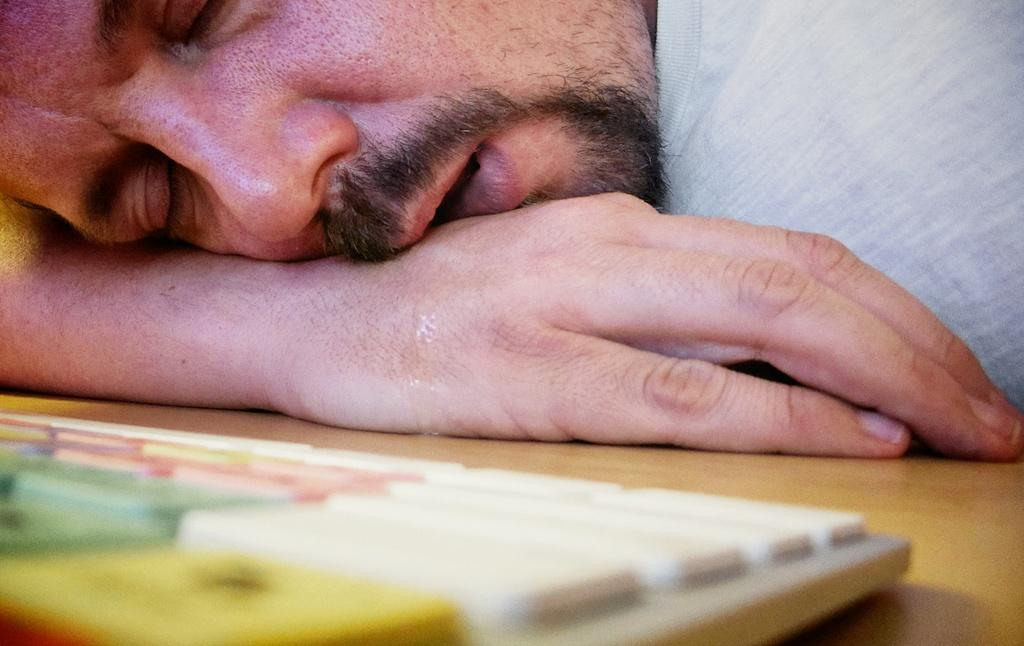Who is present in the image? There is a man in the image. What is the man doing in the image? The man is sleeping on a desk. How is the man positioned on the desk? The man has his hand under his head. What object is on the desk with the man? There is a keyboard on the desk. What type of clover is growing on the man's head in the image? There is no clover present on the man's head in the image. How is the man's brother involved in the scene depicted in the image? The image does not mention or depict a brother, so there is no information about the man's brother in the image. 